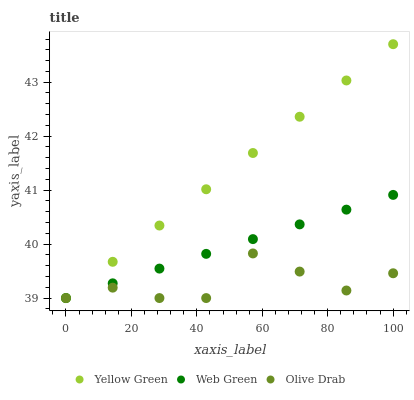Does Olive Drab have the minimum area under the curve?
Answer yes or no. Yes. Does Yellow Green have the maximum area under the curve?
Answer yes or no. Yes. Does Web Green have the minimum area under the curve?
Answer yes or no. No. Does Web Green have the maximum area under the curve?
Answer yes or no. No. Is Web Green the smoothest?
Answer yes or no. Yes. Is Olive Drab the roughest?
Answer yes or no. Yes. Is Yellow Green the smoothest?
Answer yes or no. No. Is Yellow Green the roughest?
Answer yes or no. No. Does Olive Drab have the lowest value?
Answer yes or no. Yes. Does Yellow Green have the highest value?
Answer yes or no. Yes. Does Web Green have the highest value?
Answer yes or no. No. Does Olive Drab intersect Web Green?
Answer yes or no. Yes. Is Olive Drab less than Web Green?
Answer yes or no. No. Is Olive Drab greater than Web Green?
Answer yes or no. No. 